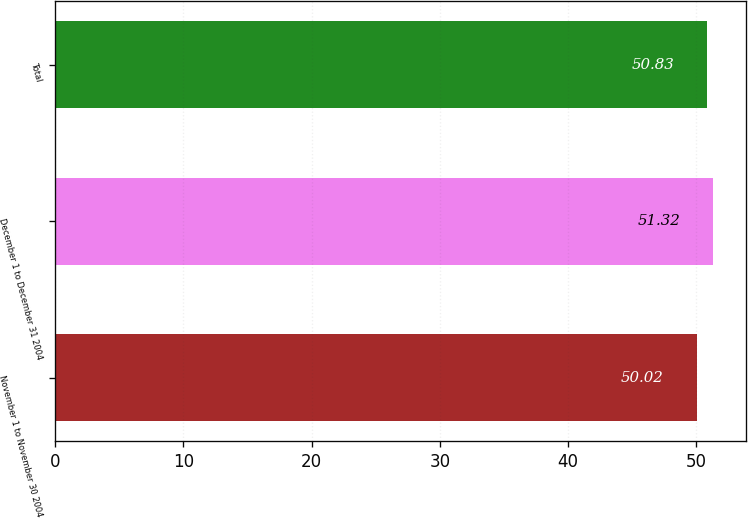<chart> <loc_0><loc_0><loc_500><loc_500><bar_chart><fcel>November 1 to November 30 2004<fcel>December 1 to December 31 2004<fcel>Total<nl><fcel>50.02<fcel>51.32<fcel>50.83<nl></chart> 